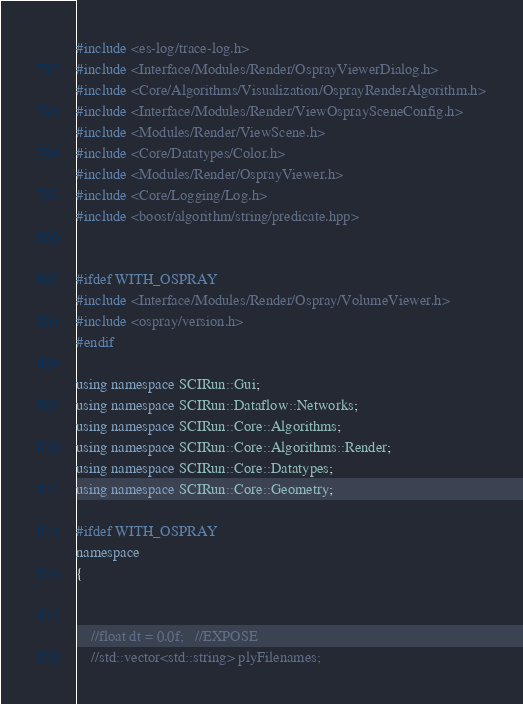Convert code to text. <code><loc_0><loc_0><loc_500><loc_500><_C++_>#include <es-log/trace-log.h>
#include <Interface/Modules/Render/OsprayViewerDialog.h>
#include <Core/Algorithms/Visualization/OsprayRenderAlgorithm.h>
#include <Interface/Modules/Render/ViewOspraySceneConfig.h>
#include <Modules/Render/ViewScene.h>
#include <Core/Datatypes/Color.h>
#include <Modules/Render/OsprayViewer.h>
#include <Core/Logging/Log.h>
#include <boost/algorithm/string/predicate.hpp>


#ifdef WITH_OSPRAY
#include <Interface/Modules/Render/Ospray/VolumeViewer.h>
#include <ospray/version.h>
#endif

using namespace SCIRun::Gui;
using namespace SCIRun::Dataflow::Networks;
using namespace SCIRun::Core::Algorithms;
using namespace SCIRun::Core::Algorithms::Render;
using namespace SCIRun::Core::Datatypes;
using namespace SCIRun::Core::Geometry;

#ifdef WITH_OSPRAY
namespace
{


    //float dt = 0.0f;   //EXPOSE
    //std::vector<std::string> plyFilenames;</code> 